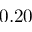<formula> <loc_0><loc_0><loc_500><loc_500>0 . 2 0</formula> 